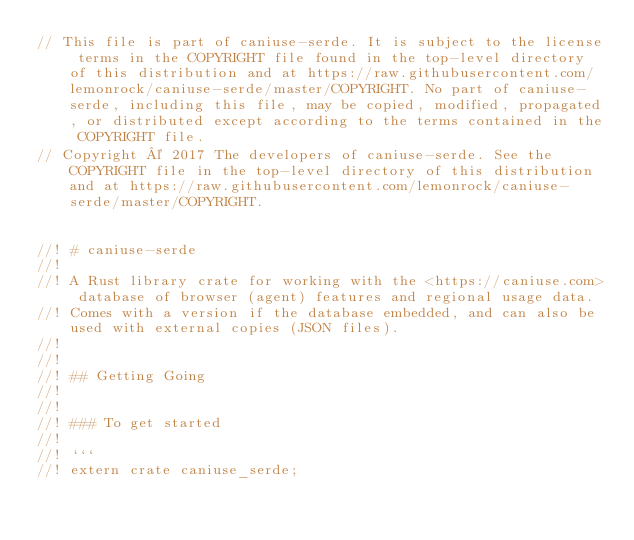<code> <loc_0><loc_0><loc_500><loc_500><_Rust_>// This file is part of caniuse-serde. It is subject to the license terms in the COPYRIGHT file found in the top-level directory of this distribution and at https://raw.githubusercontent.com/lemonrock/caniuse-serde/master/COPYRIGHT. No part of caniuse-serde, including this file, may be copied, modified, propagated, or distributed except according to the terms contained in the COPYRIGHT file.
// Copyright © 2017 The developers of caniuse-serde. See the COPYRIGHT file in the top-level directory of this distribution and at https://raw.githubusercontent.com/lemonrock/caniuse-serde/master/COPYRIGHT.


//! # caniuse-serde
//!
//! A Rust library crate for working with the <https://caniuse.com> database of browser (agent) features and regional usage data.
//! Comes with a version if the database embedded, and can also be used with external copies (JSON files).
//!
//!
//! ## Getting Going
//!
//!
//! ### To get started
//!
//! ```
//! extern crate caniuse_serde;</code> 